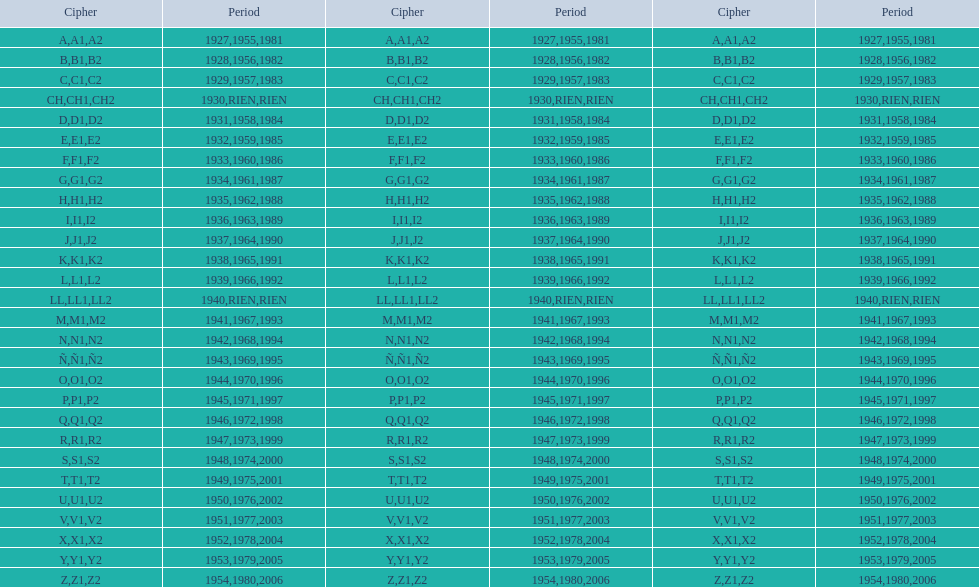What was the only year to use the code ch? 1930. 